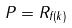<formula> <loc_0><loc_0><loc_500><loc_500>P = R _ { f ( k ) }</formula> 